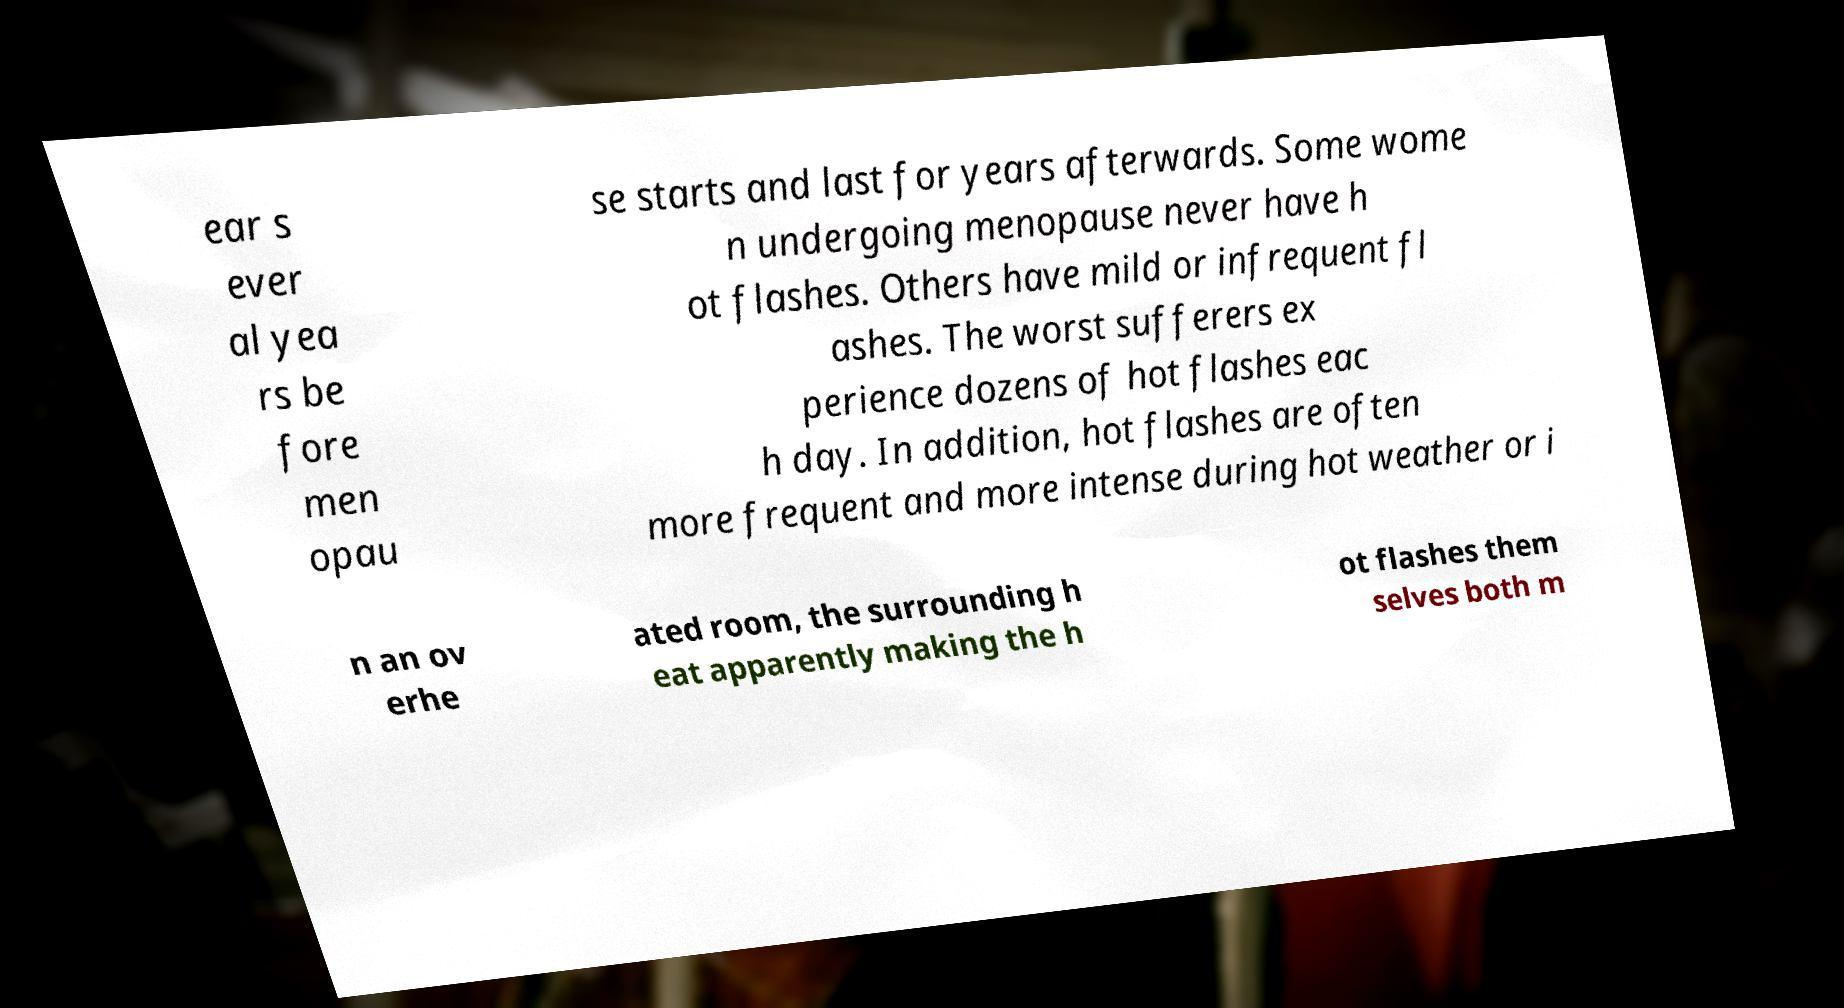I need the written content from this picture converted into text. Can you do that? ear s ever al yea rs be fore men opau se starts and last for years afterwards. Some wome n undergoing menopause never have h ot flashes. Others have mild or infrequent fl ashes. The worst sufferers ex perience dozens of hot flashes eac h day. In addition, hot flashes are often more frequent and more intense during hot weather or i n an ov erhe ated room, the surrounding h eat apparently making the h ot flashes them selves both m 